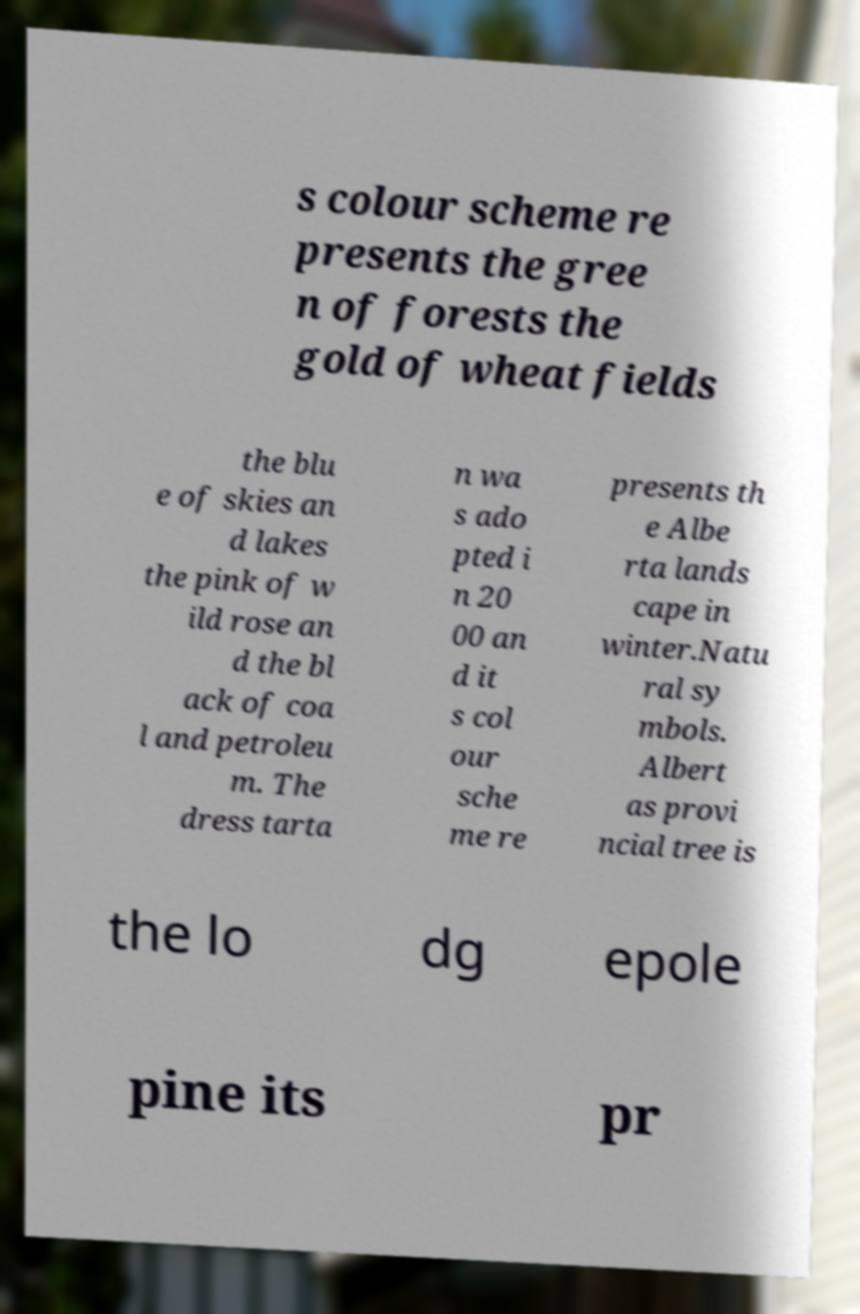Please identify and transcribe the text found in this image. s colour scheme re presents the gree n of forests the gold of wheat fields the blu e of skies an d lakes the pink of w ild rose an d the bl ack of coa l and petroleu m. The dress tarta n wa s ado pted i n 20 00 an d it s col our sche me re presents th e Albe rta lands cape in winter.Natu ral sy mbols. Albert as provi ncial tree is the lo dg epole pine its pr 